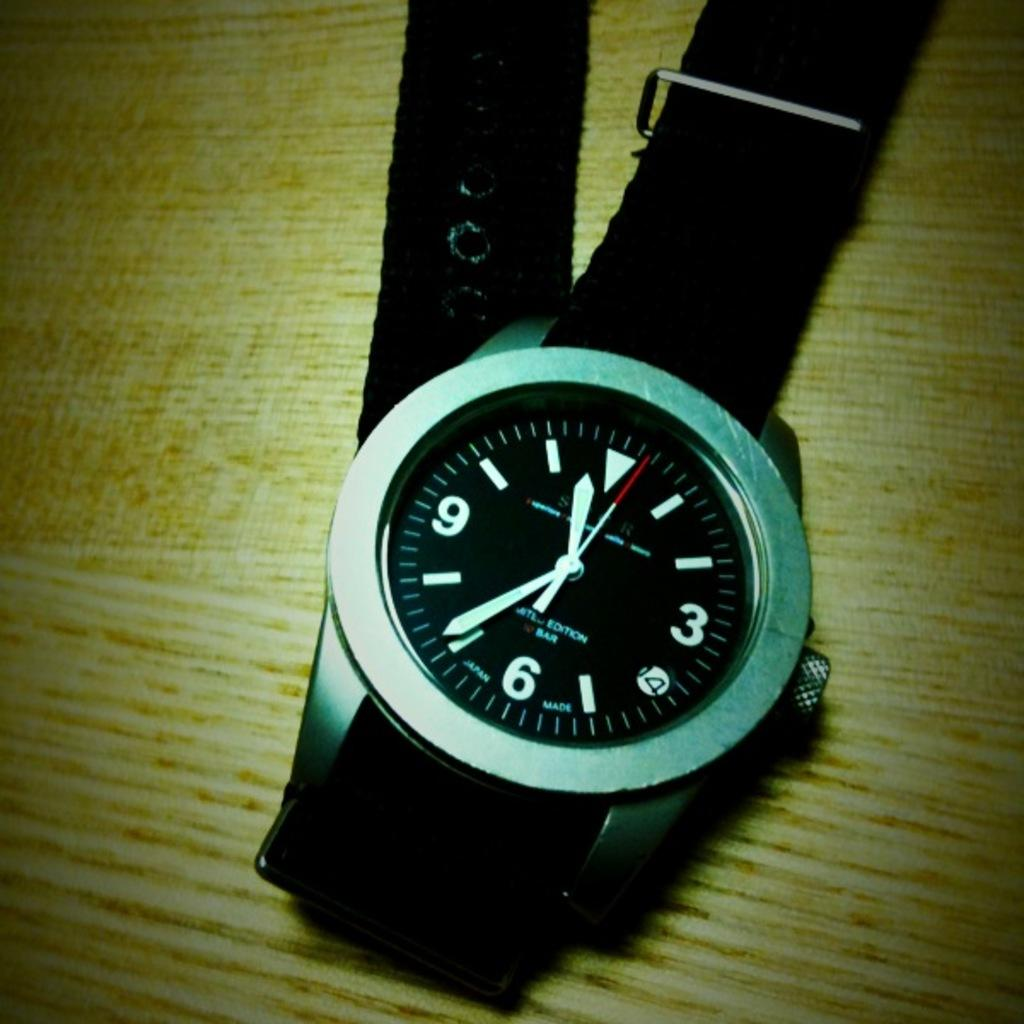Provide a one-sentence caption for the provided image. The black faced watch with a black band shows the time of 11:36. 